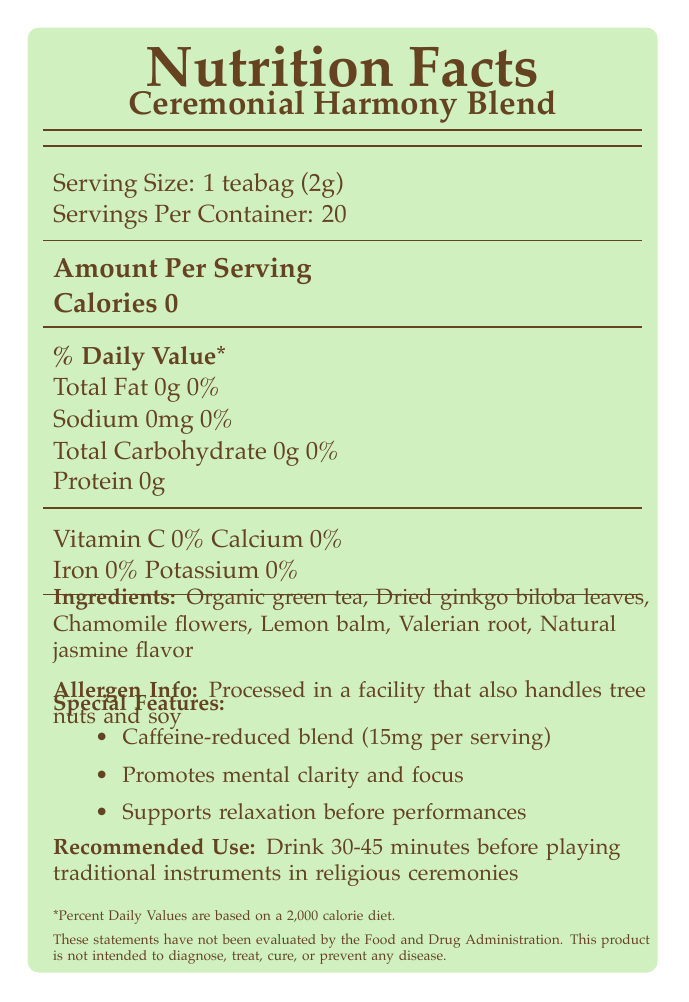What is the serving size of Ceremonial Harmony Blend? The serving size is listed as "1 teabag (2g)" in the document.
Answer: 1 teabag (2g) How many servings are in one container? The document specifies "Servings Per Container: 20".
Answer: 20 How much caffeine is in one serving of the tea? The document states "Caffeine-reduced blend (15mg per serving)" under the special features section.
Answer: 15mg What are the main ingredients of Ceremonial Harmony Blend? The ingredients are listed under the "Ingredients" section of the document.
Answer: Organic green tea, Dried ginkgo biloba leaves, Chamomile flowers, Lemon balm, Valerian root, Natural jasmine flavor Are there any vitamins or minerals in this tea blend? The document states that Vitamin C, Calcium, Iron, and Potassium are all at 0%.
Answer: No Is there any fat content in Ceremonial Harmony Blend? The document lists "Total Fat 0g" with a daily value percentage of 0%.
Answer: No For what purpose is this specialty tea blend recommended? The "Recommended Use" section specifies this usage.
Answer: To drink 30-45 minutes before playing traditional instruments in religious ceremonies What should you avoid if you have a tree nut or soy allergy? A. Dairy B. Gluten C. Ceremonial Harmony Blend The allergen information states that the tea is "Processed in a facility that also handles tree nuts and soy".
Answer: C. Ceremonial Harmony Blend Where is the best before date located? a) On the lid b) On the bottom of the package c) On the side of the package The storage instructions specify "See bottom of package".
Answer: b) On the bottom of the package Is Ceremonial Harmony Blend intended to diagnose, treat, cure, or prevent any disease? The disclaimer states that this product is not intended to diagnose, treat, cure, or prevent any disease.
Answer: No Does Ceremonial Harmony Blend contain any calories? The document lists "Calories 0" per serving.
Answer: No Summarize the main features and intended use of Ceremonial Harmony Blend. This summary captures all key points including the nutritional content, ingredients, special features, certifications, and recommended use.
Answer: Ceremonial Harmony Blend is a specialty tea with no calories, fat, sodium, carbohydrates, or protein. Each serving contains 15mg of caffeine and it is made with organic green tea, dried ginkgo biloba leaves, chamomile flowers, lemon balm, valerian root, and natural jasmine flavor. The blend is caffeine-reduced and promotes mental clarity and relaxation before performances. It is recommended to drink 30-45 minutes before playing traditional instruments in religious ceremonies. The tea is processed in a facility that also handles tree nuts and soy, and it is certified USDA Organic, Fair Trade Certified, and Non-GMO Project Verified. It is not intended to diagnose, treat, cure, or prevent any disease. Which company manufactures Ceremonial Harmony Blend? The manufacturer is listed as "Sacred Sounds Tea Co." in the document.
Answer: Sacred Sounds Tea Co. What is the country of origin for Ceremonial Harmony Blend? The document states "Blend of teas from Japan, China, and India".
Answer: Blend of teas from Japan, China, and India What is the recommended water temperature for steeping the tea? The recommended preparation section specifies "Steep in hot water (80°C/175°F)".
Answer: 80°C/175°F What should you do if you need more information about the product? The contact section provides these details for more information.
Answer: Visit www.sacredsoundstea.com, call 1-800-555-TEA1, or email info@sacredsoundstea.com How much Valerian root is in each serving? The document lists Valerian root as an ingredient but does not specify the exact amount in each serving.
Answer: Cannot be determined 